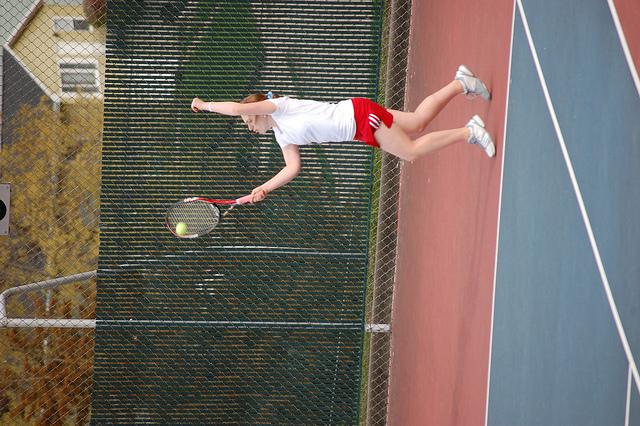Will the yellow ball hit the tennis webbing of the tennis racket?
Write a very short answer. Yes. Are these new sneakers?
Short answer required. No. What color shorts is she wearing?
Answer briefly. Red. 